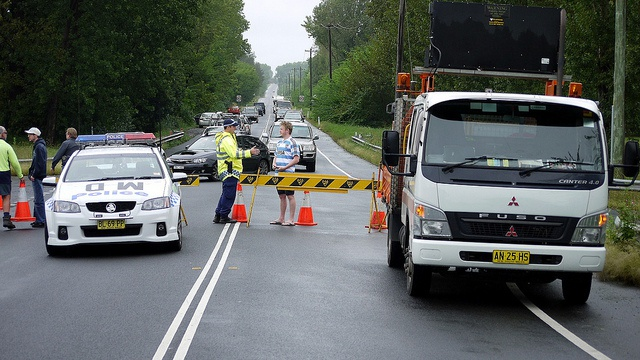Describe the objects in this image and their specific colors. I can see truck in black, gray, darkgray, and lightgray tones, car in black, lightgray, and darkgray tones, car in black, darkgray, lightgray, and gray tones, people in black, khaki, navy, and darkgray tones, and people in black, darkgray, lightgray, and gray tones in this image. 